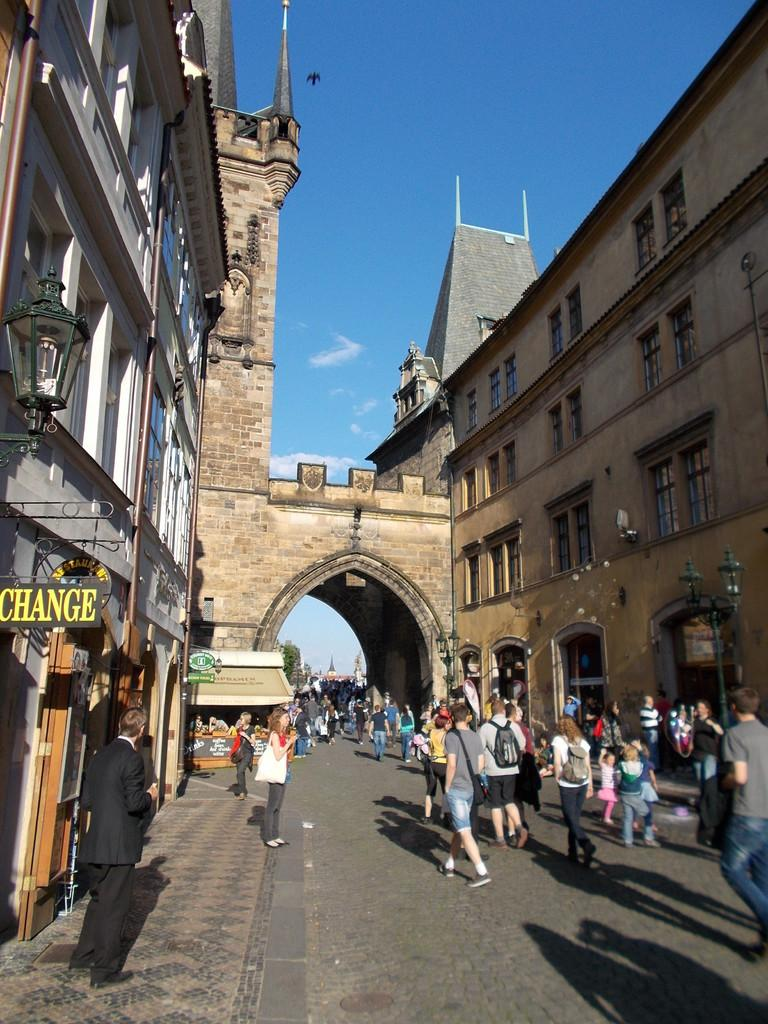What type of structures can be seen in the image? There are buildings with windows in the image. Are there any living beings visible in the image? Yes, people are visible in the image. What is located on the left side of the image? There is a board and a light on the left side of the image. What is the color of the sky in the image? The sky is blue in color. Can you describe any animals in the image? Yes, a bird is flying in the air. What day of the week is it in the image? The day of the week is not mentioned or visible in the image. How many brothers are present in the image? There is no mention of brothers in the image. What type of clothing is the bird wearing in the image? The bird is a flying animal and does not wear clothing. 